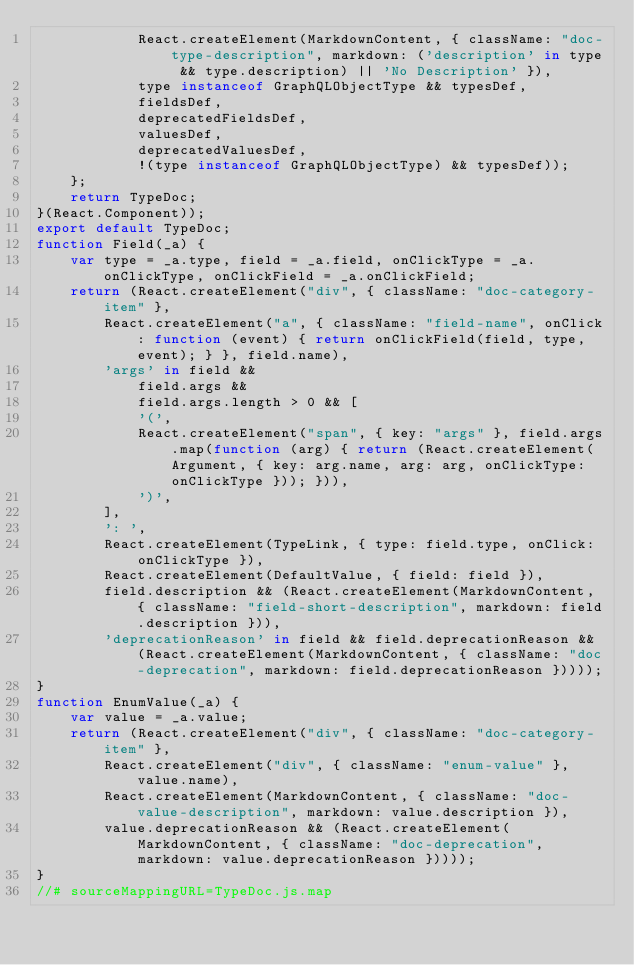<code> <loc_0><loc_0><loc_500><loc_500><_JavaScript_>            React.createElement(MarkdownContent, { className: "doc-type-description", markdown: ('description' in type && type.description) || 'No Description' }),
            type instanceof GraphQLObjectType && typesDef,
            fieldsDef,
            deprecatedFieldsDef,
            valuesDef,
            deprecatedValuesDef,
            !(type instanceof GraphQLObjectType) && typesDef));
    };
    return TypeDoc;
}(React.Component));
export default TypeDoc;
function Field(_a) {
    var type = _a.type, field = _a.field, onClickType = _a.onClickType, onClickField = _a.onClickField;
    return (React.createElement("div", { className: "doc-category-item" },
        React.createElement("a", { className: "field-name", onClick: function (event) { return onClickField(field, type, event); } }, field.name),
        'args' in field &&
            field.args &&
            field.args.length > 0 && [
            '(',
            React.createElement("span", { key: "args" }, field.args.map(function (arg) { return (React.createElement(Argument, { key: arg.name, arg: arg, onClickType: onClickType })); })),
            ')',
        ],
        ': ',
        React.createElement(TypeLink, { type: field.type, onClick: onClickType }),
        React.createElement(DefaultValue, { field: field }),
        field.description && (React.createElement(MarkdownContent, { className: "field-short-description", markdown: field.description })),
        'deprecationReason' in field && field.deprecationReason && (React.createElement(MarkdownContent, { className: "doc-deprecation", markdown: field.deprecationReason }))));
}
function EnumValue(_a) {
    var value = _a.value;
    return (React.createElement("div", { className: "doc-category-item" },
        React.createElement("div", { className: "enum-value" }, value.name),
        React.createElement(MarkdownContent, { className: "doc-value-description", markdown: value.description }),
        value.deprecationReason && (React.createElement(MarkdownContent, { className: "doc-deprecation", markdown: value.deprecationReason }))));
}
//# sourceMappingURL=TypeDoc.js.map</code> 